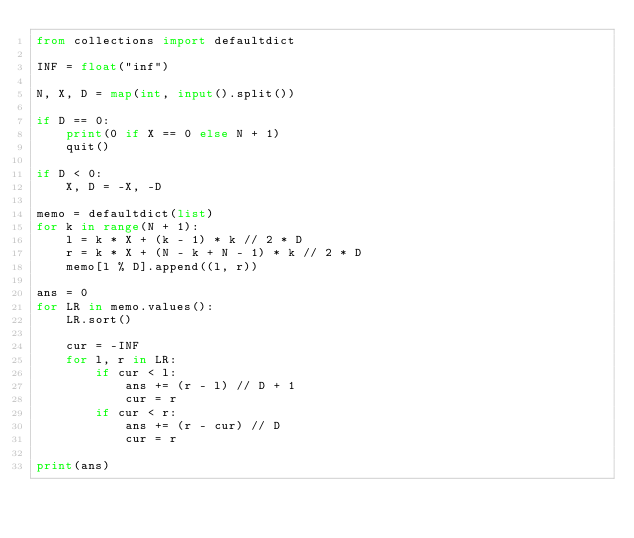<code> <loc_0><loc_0><loc_500><loc_500><_Python_>from collections import defaultdict

INF = float("inf")

N, X, D = map(int, input().split())

if D == 0:
    print(0 if X == 0 else N + 1)
    quit()

if D < 0:
    X, D = -X, -D

memo = defaultdict(list)
for k in range(N + 1):
    l = k * X + (k - 1) * k // 2 * D
    r = k * X + (N - k + N - 1) * k // 2 * D
    memo[l % D].append((l, r))

ans = 0
for LR in memo.values():
    LR.sort()

    cur = -INF
    for l, r in LR:
        if cur < l:
            ans += (r - l) // D + 1
            cur = r
        if cur < r:
            ans += (r - cur) // D
            cur = r

print(ans)</code> 